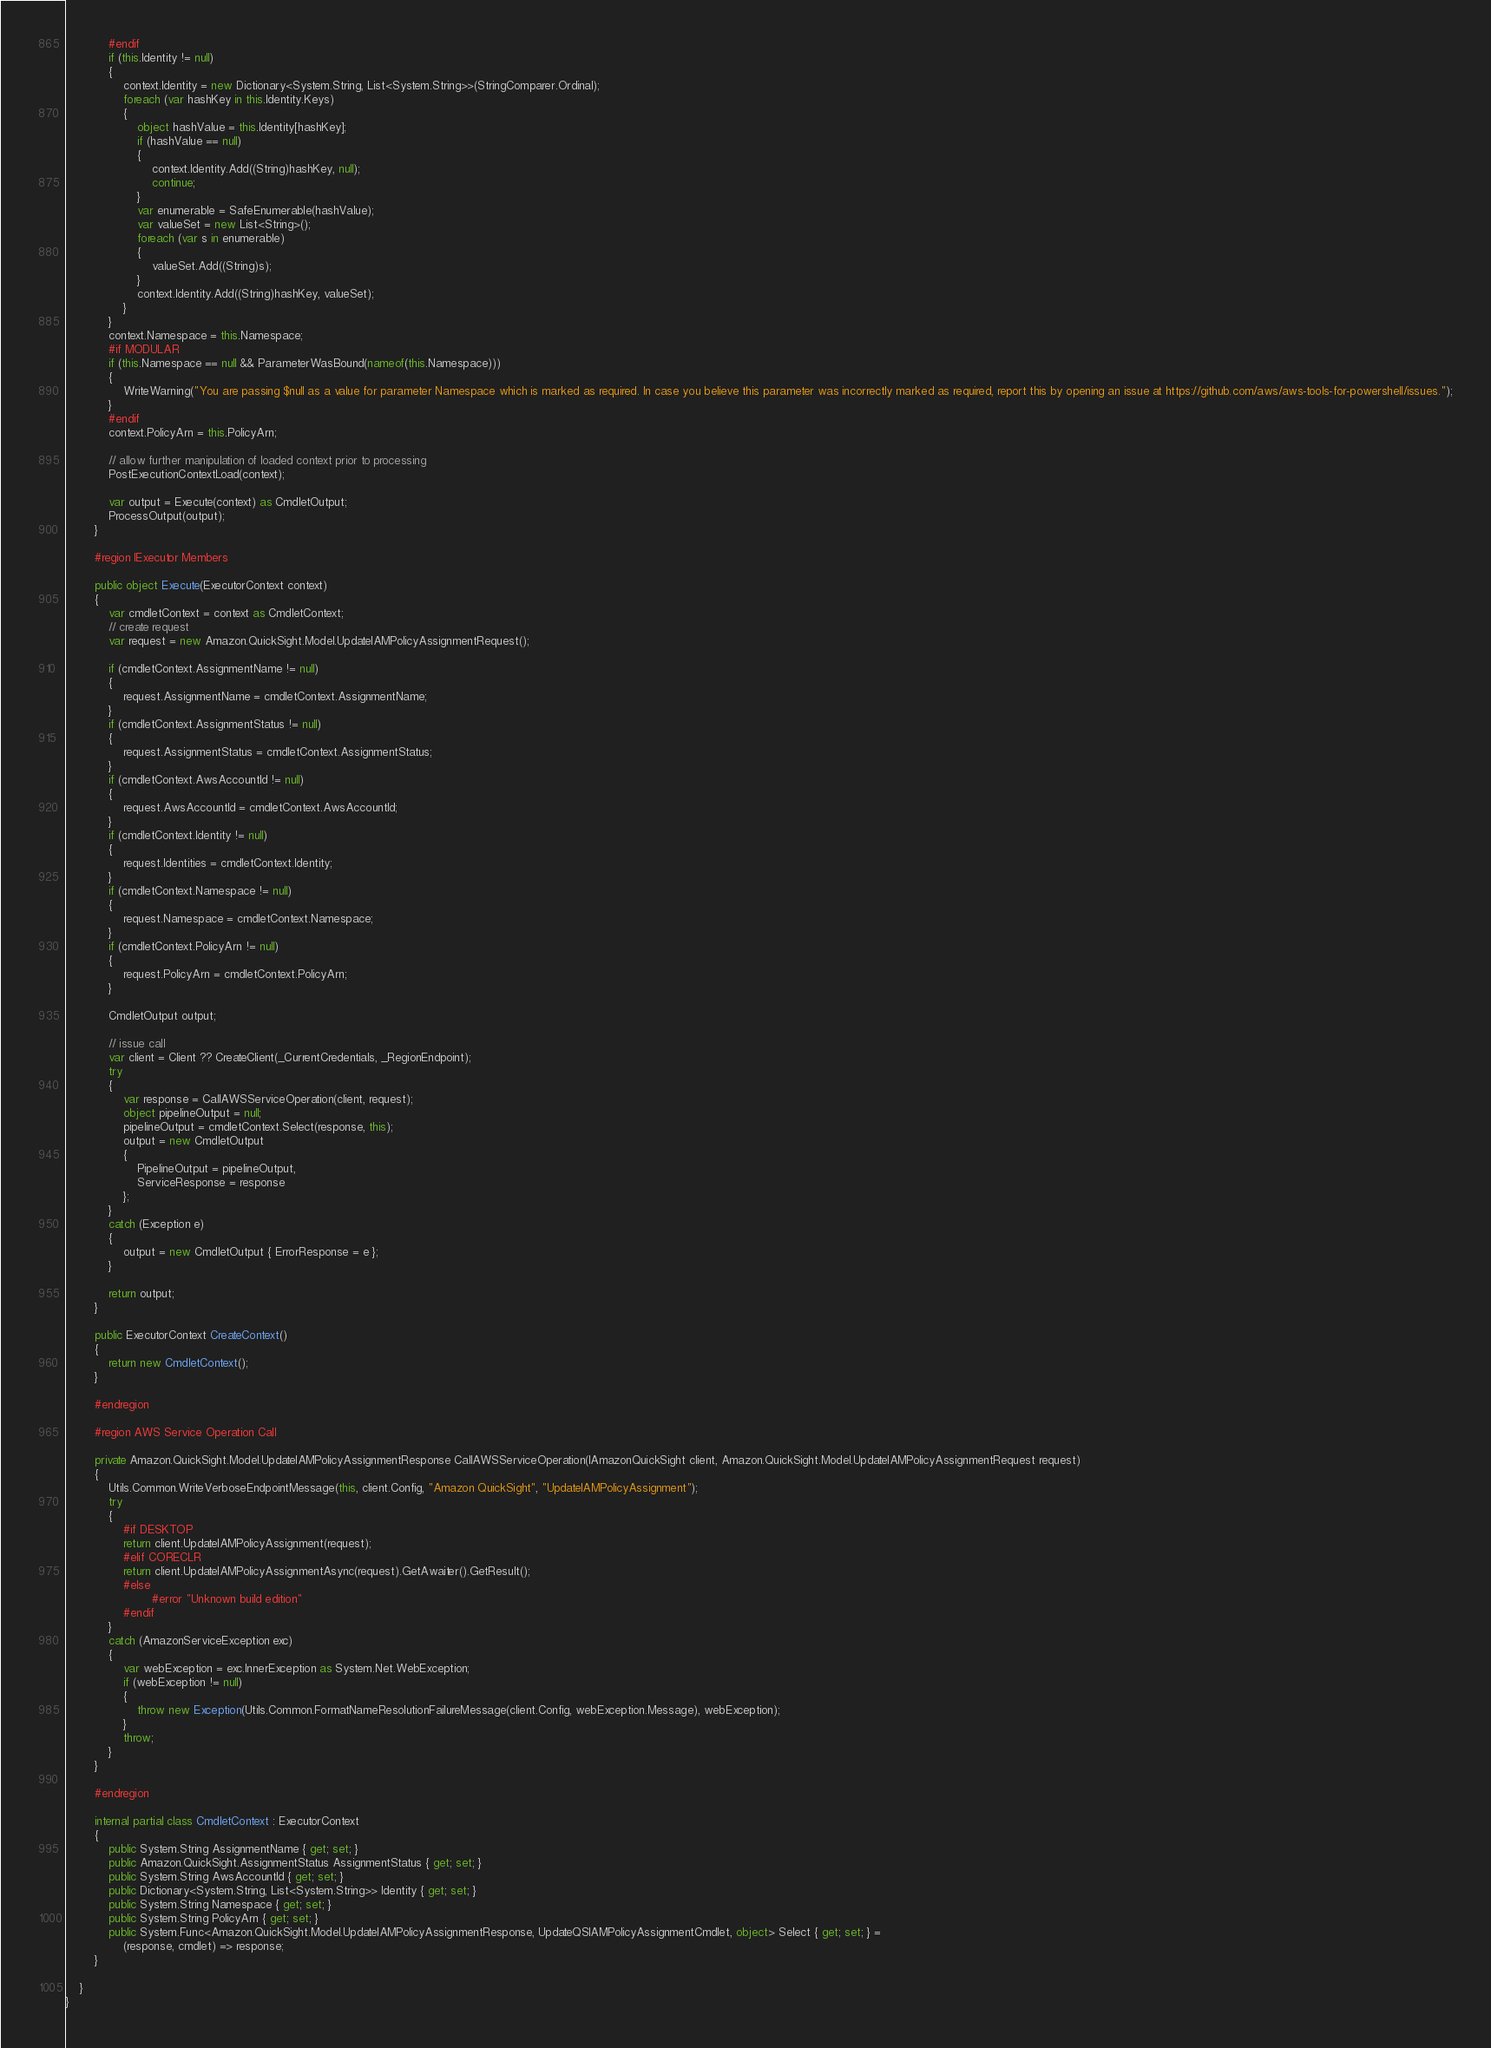Convert code to text. <code><loc_0><loc_0><loc_500><loc_500><_C#_>            #endif
            if (this.Identity != null)
            {
                context.Identity = new Dictionary<System.String, List<System.String>>(StringComparer.Ordinal);
                foreach (var hashKey in this.Identity.Keys)
                {
                    object hashValue = this.Identity[hashKey];
                    if (hashValue == null)
                    {
                        context.Identity.Add((String)hashKey, null);
                        continue;
                    }
                    var enumerable = SafeEnumerable(hashValue);
                    var valueSet = new List<String>();
                    foreach (var s in enumerable)
                    {
                        valueSet.Add((String)s);
                    }
                    context.Identity.Add((String)hashKey, valueSet);
                }
            }
            context.Namespace = this.Namespace;
            #if MODULAR
            if (this.Namespace == null && ParameterWasBound(nameof(this.Namespace)))
            {
                WriteWarning("You are passing $null as a value for parameter Namespace which is marked as required. In case you believe this parameter was incorrectly marked as required, report this by opening an issue at https://github.com/aws/aws-tools-for-powershell/issues.");
            }
            #endif
            context.PolicyArn = this.PolicyArn;
            
            // allow further manipulation of loaded context prior to processing
            PostExecutionContextLoad(context);
            
            var output = Execute(context) as CmdletOutput;
            ProcessOutput(output);
        }
        
        #region IExecutor Members
        
        public object Execute(ExecutorContext context)
        {
            var cmdletContext = context as CmdletContext;
            // create request
            var request = new Amazon.QuickSight.Model.UpdateIAMPolicyAssignmentRequest();
            
            if (cmdletContext.AssignmentName != null)
            {
                request.AssignmentName = cmdletContext.AssignmentName;
            }
            if (cmdletContext.AssignmentStatus != null)
            {
                request.AssignmentStatus = cmdletContext.AssignmentStatus;
            }
            if (cmdletContext.AwsAccountId != null)
            {
                request.AwsAccountId = cmdletContext.AwsAccountId;
            }
            if (cmdletContext.Identity != null)
            {
                request.Identities = cmdletContext.Identity;
            }
            if (cmdletContext.Namespace != null)
            {
                request.Namespace = cmdletContext.Namespace;
            }
            if (cmdletContext.PolicyArn != null)
            {
                request.PolicyArn = cmdletContext.PolicyArn;
            }
            
            CmdletOutput output;
            
            // issue call
            var client = Client ?? CreateClient(_CurrentCredentials, _RegionEndpoint);
            try
            {
                var response = CallAWSServiceOperation(client, request);
                object pipelineOutput = null;
                pipelineOutput = cmdletContext.Select(response, this);
                output = new CmdletOutput
                {
                    PipelineOutput = pipelineOutput,
                    ServiceResponse = response
                };
            }
            catch (Exception e)
            {
                output = new CmdletOutput { ErrorResponse = e };
            }
            
            return output;
        }
        
        public ExecutorContext CreateContext()
        {
            return new CmdletContext();
        }
        
        #endregion
        
        #region AWS Service Operation Call
        
        private Amazon.QuickSight.Model.UpdateIAMPolicyAssignmentResponse CallAWSServiceOperation(IAmazonQuickSight client, Amazon.QuickSight.Model.UpdateIAMPolicyAssignmentRequest request)
        {
            Utils.Common.WriteVerboseEndpointMessage(this, client.Config, "Amazon QuickSight", "UpdateIAMPolicyAssignment");
            try
            {
                #if DESKTOP
                return client.UpdateIAMPolicyAssignment(request);
                #elif CORECLR
                return client.UpdateIAMPolicyAssignmentAsync(request).GetAwaiter().GetResult();
                #else
                        #error "Unknown build edition"
                #endif
            }
            catch (AmazonServiceException exc)
            {
                var webException = exc.InnerException as System.Net.WebException;
                if (webException != null)
                {
                    throw new Exception(Utils.Common.FormatNameResolutionFailureMessage(client.Config, webException.Message), webException);
                }
                throw;
            }
        }
        
        #endregion
        
        internal partial class CmdletContext : ExecutorContext
        {
            public System.String AssignmentName { get; set; }
            public Amazon.QuickSight.AssignmentStatus AssignmentStatus { get; set; }
            public System.String AwsAccountId { get; set; }
            public Dictionary<System.String, List<System.String>> Identity { get; set; }
            public System.String Namespace { get; set; }
            public System.String PolicyArn { get; set; }
            public System.Func<Amazon.QuickSight.Model.UpdateIAMPolicyAssignmentResponse, UpdateQSIAMPolicyAssignmentCmdlet, object> Select { get; set; } =
                (response, cmdlet) => response;
        }
        
    }
}
</code> 